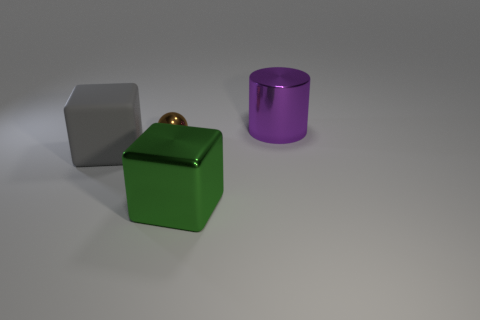Do the gray cube and the purple metal object have the same size?
Offer a very short reply. Yes. Is the number of cylinders greater than the number of blue rubber balls?
Give a very brief answer. Yes. What number of other objects are there of the same color as the large cylinder?
Offer a terse response. 0. What number of objects are brown cubes or large rubber cubes?
Make the answer very short. 1. Do the big shiny object that is behind the big green cube and the green object have the same shape?
Provide a short and direct response. No. What color is the large metal thing that is to the left of the object right of the large green thing?
Offer a very short reply. Green. Is the number of gray spheres less than the number of large rubber things?
Provide a short and direct response. Yes. Is there a green block made of the same material as the purple cylinder?
Ensure brevity in your answer.  Yes. There is a large gray thing; is it the same shape as the big metallic thing that is on the left side of the large purple shiny cylinder?
Provide a short and direct response. Yes. Are there any cubes behind the big cylinder?
Keep it short and to the point. No. 